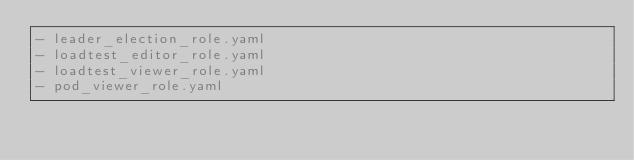<code> <loc_0><loc_0><loc_500><loc_500><_YAML_>- leader_election_role.yaml
- loadtest_editor_role.yaml
- loadtest_viewer_role.yaml
- pod_viewer_role.yaml
</code> 